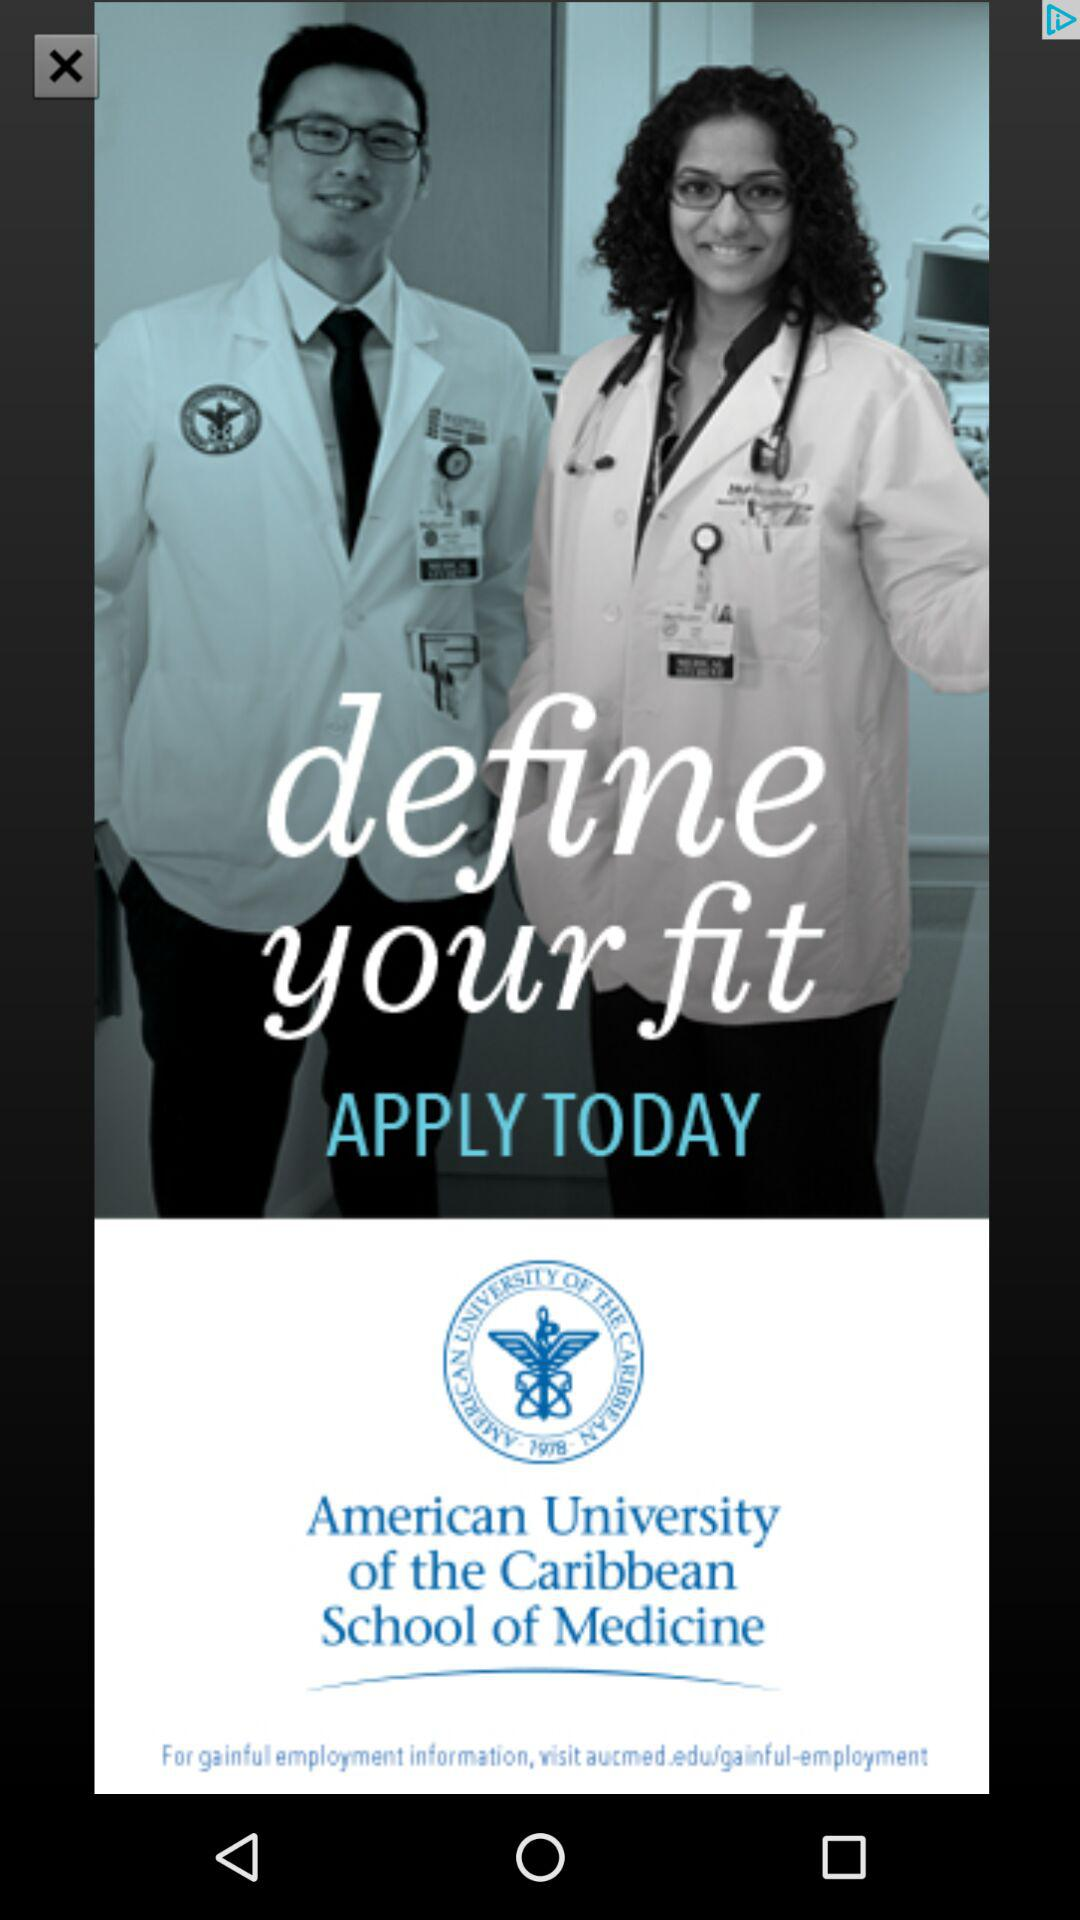What is the application name?
When the provided information is insufficient, respond with <no answer>. <no answer> 